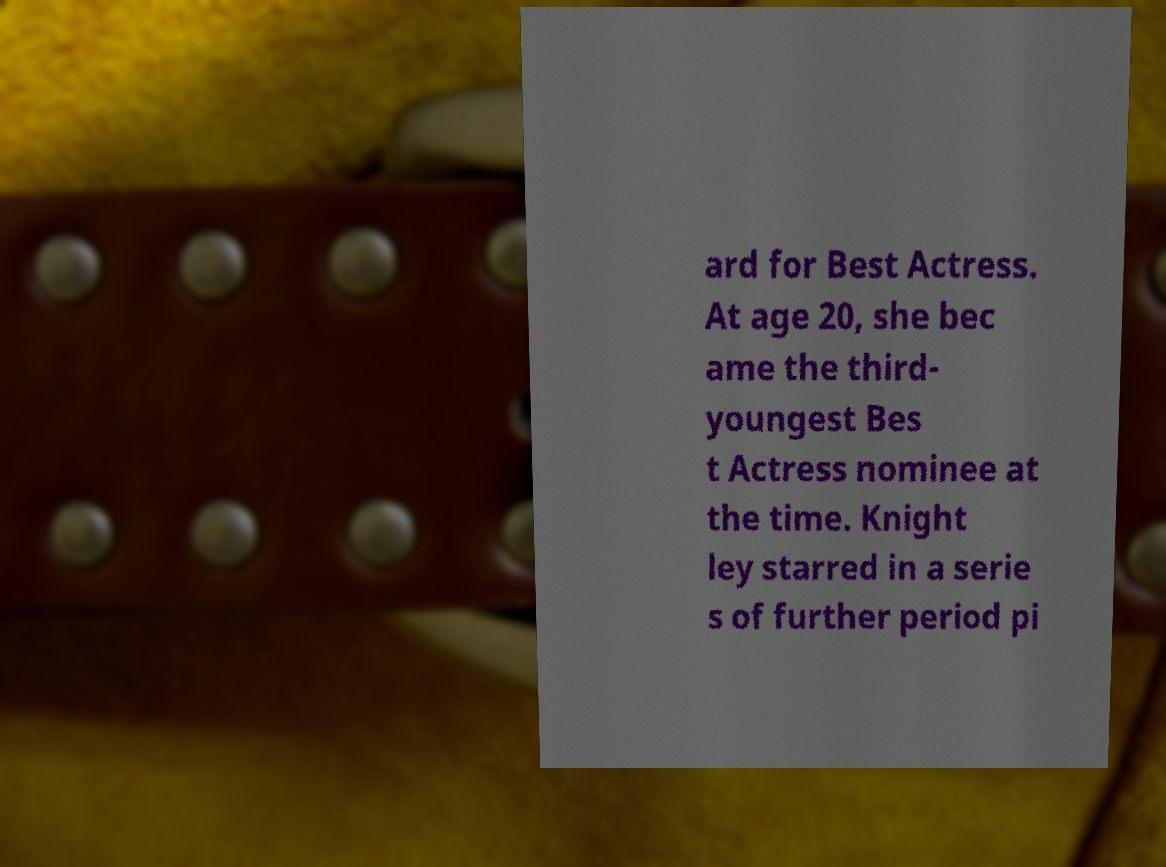Please identify and transcribe the text found in this image. ard for Best Actress. At age 20, she bec ame the third- youngest Bes t Actress nominee at the time. Knight ley starred in a serie s of further period pi 